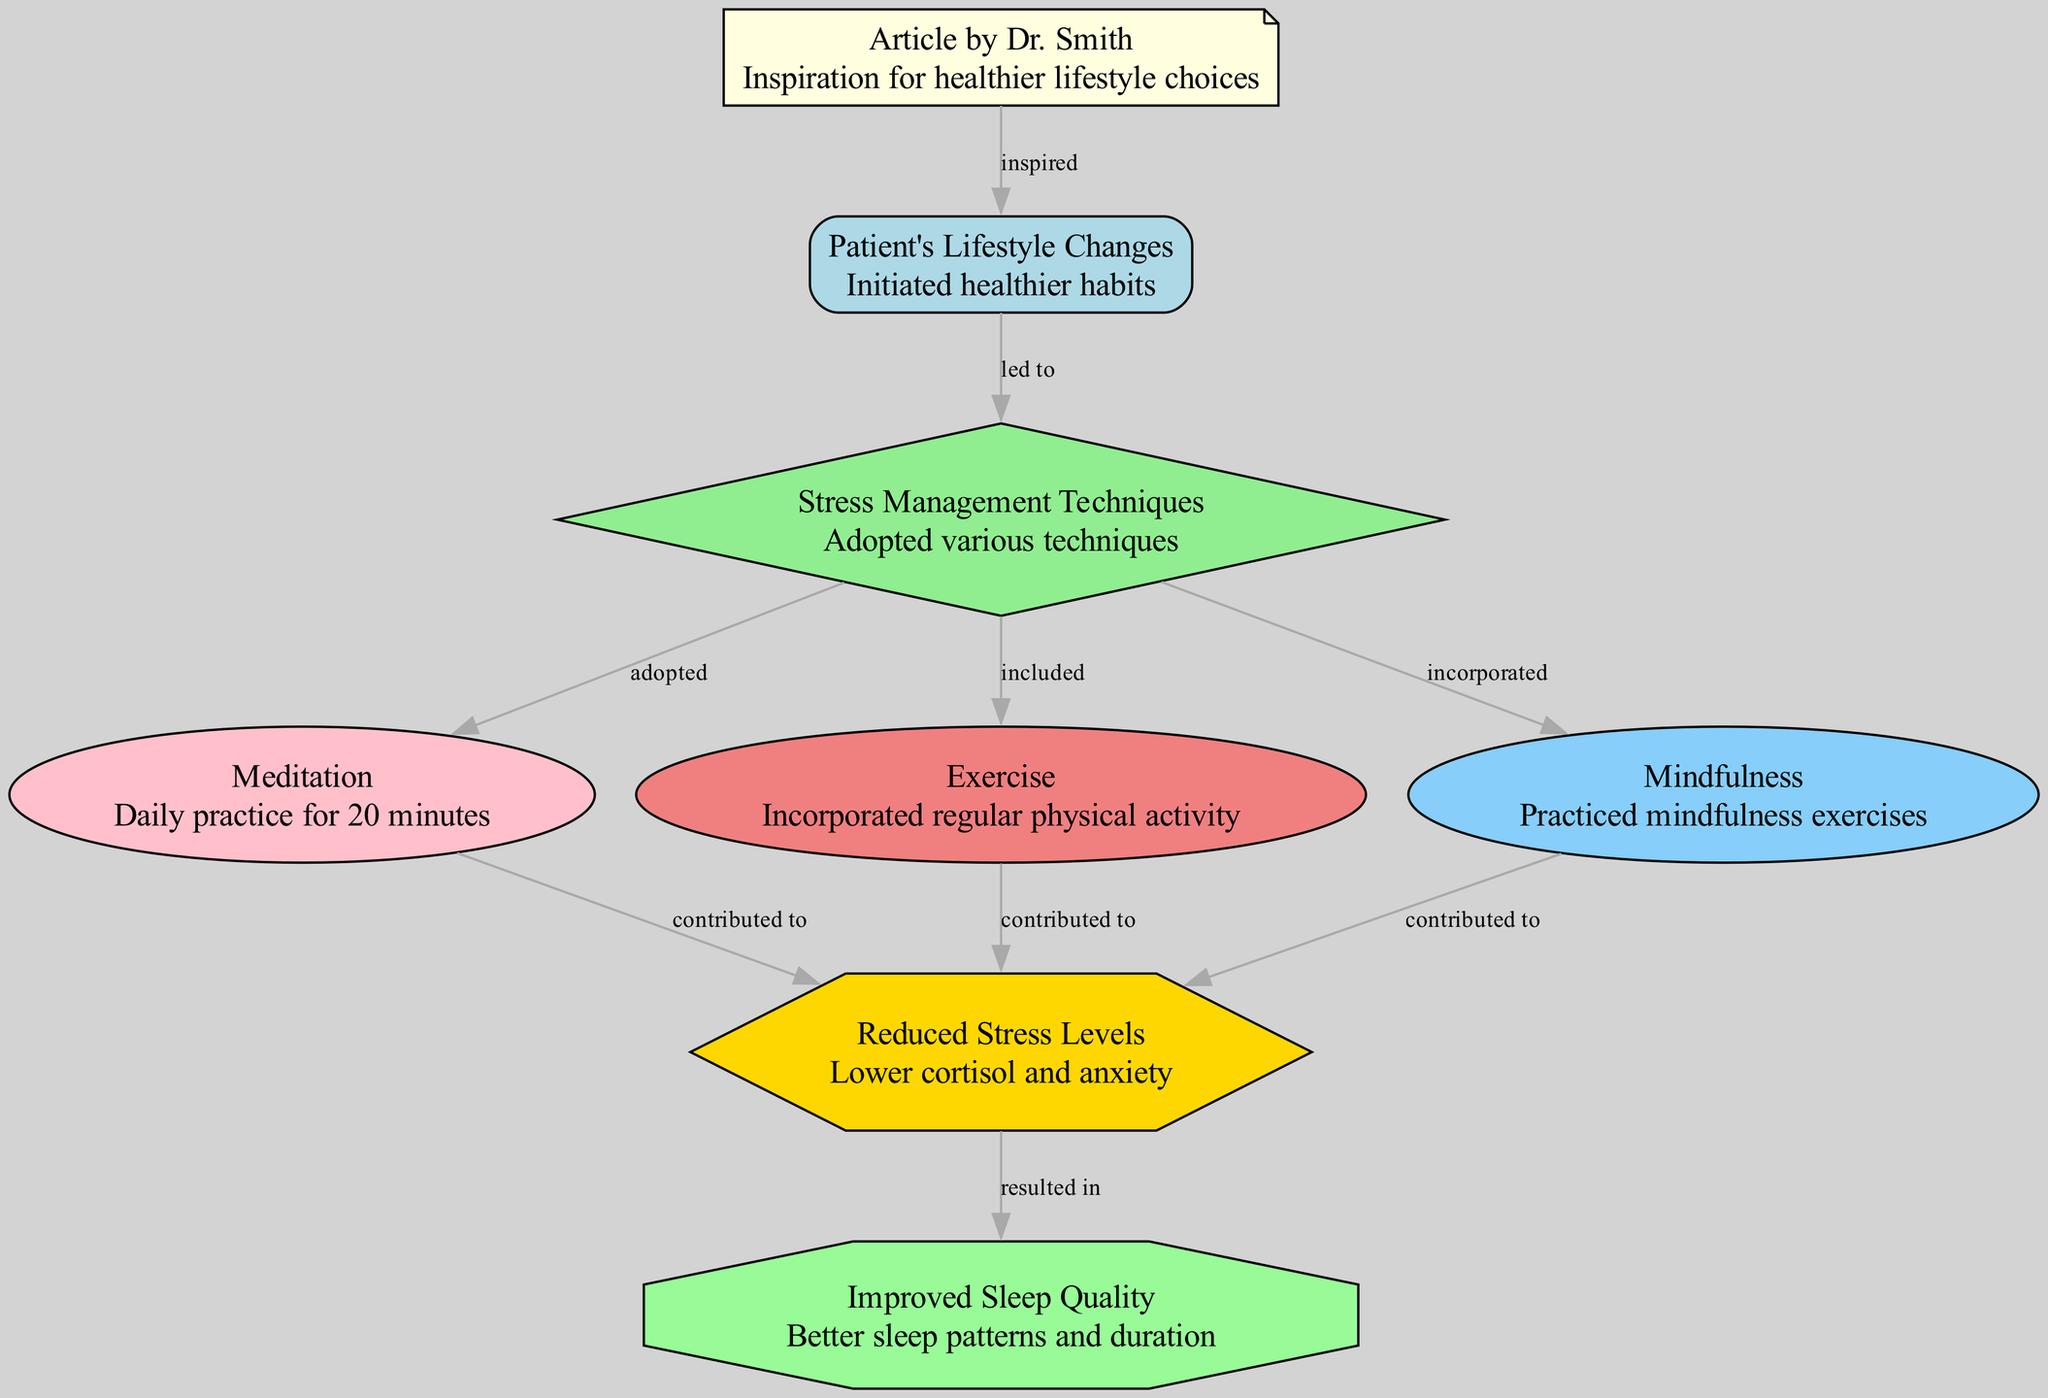What inspired the lifestyle changes in the patient? The diagram shows that the article by Dr. Smith inspired the patient to make healthier lifestyle choices. Therefore, we see a direct connection from the node labeled "Article by Dr. Smith" to "Patient's Lifestyle Changes."
Answer: Article by Dr. Smith How many techniques for stress management are listed in the diagram? The diagram lists three techniques for stress management: Meditation, Exercise, and Mindfulness. This can be determined by counting the connections from the node "Stress Management Techniques" to these three specific nodes.
Answer: Three What is the outcome of reduced stress levels? According to the diagram, reduced stress levels lead to improved sleep quality. The edge from "Reduced Stress Levels" to "Improved Sleep Quality" indicates this relationship.
Answer: Improved Sleep Quality Which stress management technique contributed to lower stress levels? The diagram indicates that all three techniques (Meditation, Exercise, and Mindfulness) contributed to lower stress levels, as there are edges showing a direct contribution from each technique to the "Reduced Stress Levels" node.
Answer: Meditation, Exercise, Mindfulness What is the relationship between the article and sleep quality? The article by Dr. Smith inspires lifestyle changes that lead to the adoption of stress management techniques, which subsequently result in improved sleep quality. The flow from the article to lifestyle changes, then to stress management techniques, and finally to sleep quality outlines this causal chain.
Answer: Inspired lifestyle changes lead to improved sleep quality 